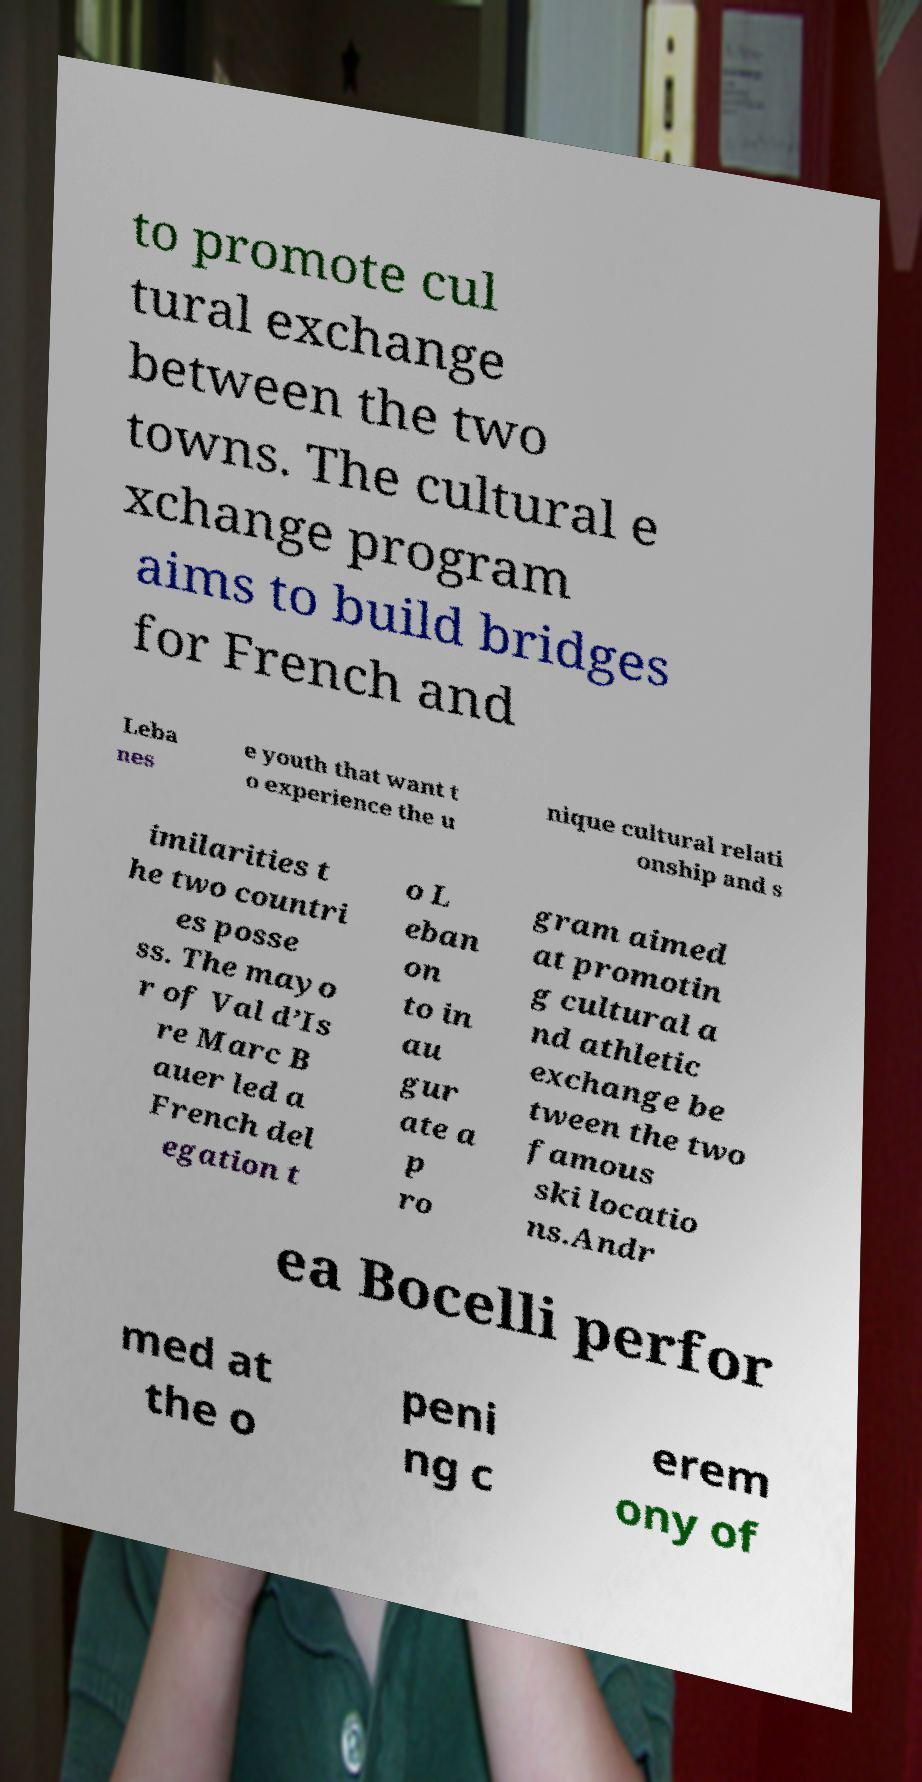Could you assist in decoding the text presented in this image and type it out clearly? to promote cul tural exchange between the two towns. The cultural e xchange program aims to build bridges for French and Leba nes e youth that want t o experience the u nique cultural relati onship and s imilarities t he two countri es posse ss. The mayo r of Val d’Is re Marc B auer led a French del egation t o L eban on to in au gur ate a p ro gram aimed at promotin g cultural a nd athletic exchange be tween the two famous ski locatio ns.Andr ea Bocelli perfor med at the o peni ng c erem ony of 